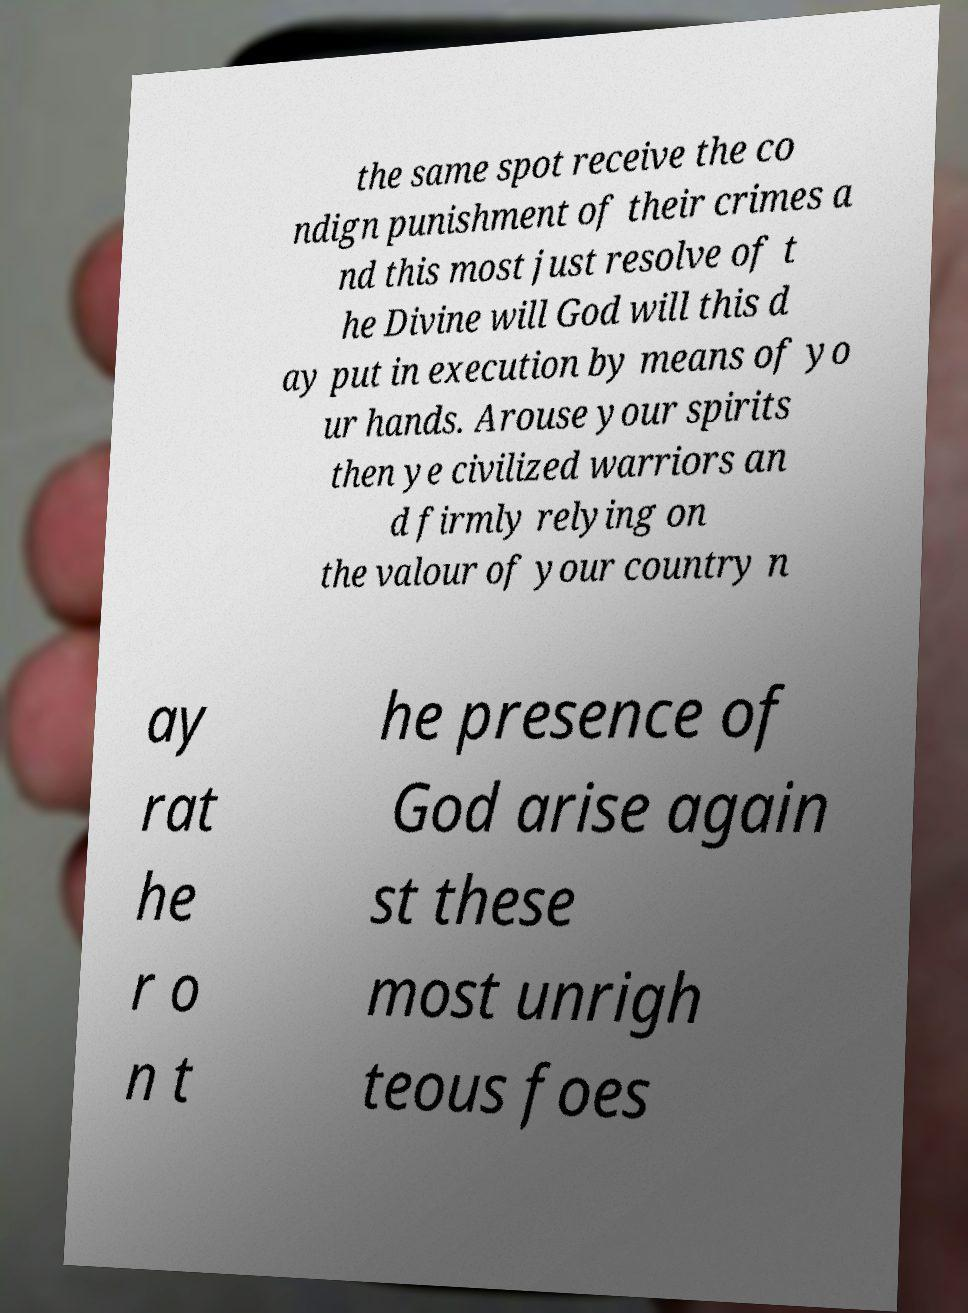What messages or text are displayed in this image? I need them in a readable, typed format. the same spot receive the co ndign punishment of their crimes a nd this most just resolve of t he Divine will God will this d ay put in execution by means of yo ur hands. Arouse your spirits then ye civilized warriors an d firmly relying on the valour of your country n ay rat he r o n t he presence of God arise again st these most unrigh teous foes 